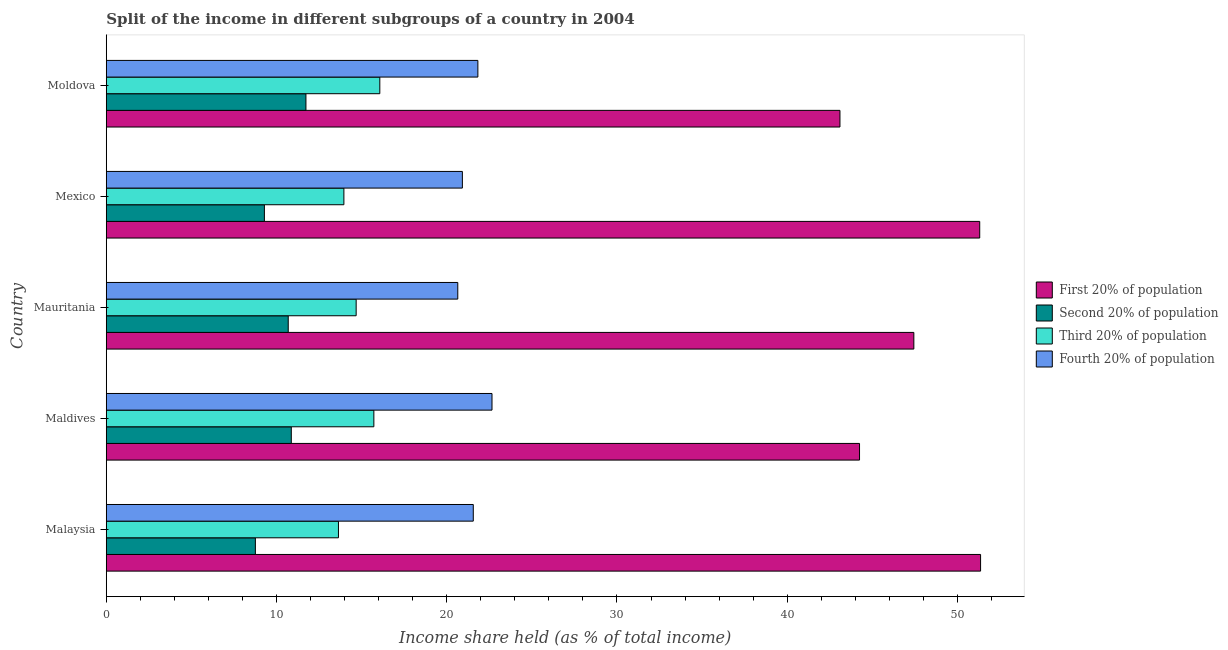How many groups of bars are there?
Your response must be concise. 5. Are the number of bars per tick equal to the number of legend labels?
Your answer should be compact. Yes. How many bars are there on the 2nd tick from the top?
Provide a succinct answer. 4. What is the label of the 4th group of bars from the top?
Keep it short and to the point. Maldives. In how many cases, is the number of bars for a given country not equal to the number of legend labels?
Offer a very short reply. 0. What is the share of the income held by third 20% of the population in Moldova?
Offer a very short reply. 16.07. Across all countries, what is the maximum share of the income held by first 20% of the population?
Your answer should be very brief. 51.36. Across all countries, what is the minimum share of the income held by third 20% of the population?
Provide a short and direct response. 13.64. In which country was the share of the income held by second 20% of the population maximum?
Give a very brief answer. Moldova. In which country was the share of the income held by first 20% of the population minimum?
Your answer should be very brief. Moldova. What is the total share of the income held by third 20% of the population in the graph?
Your answer should be very brief. 74.07. What is the difference between the share of the income held by fourth 20% of the population in Malaysia and that in Mauritania?
Make the answer very short. 0.91. What is the difference between the share of the income held by third 20% of the population in Mexico and the share of the income held by fourth 20% of the population in Mauritania?
Your answer should be very brief. -6.69. What is the average share of the income held by third 20% of the population per country?
Your response must be concise. 14.81. What is the difference between the share of the income held by second 20% of the population and share of the income held by fourth 20% of the population in Maldives?
Give a very brief answer. -11.79. In how many countries, is the share of the income held by first 20% of the population greater than 44 %?
Give a very brief answer. 4. What is the ratio of the share of the income held by first 20% of the population in Mauritania to that in Mexico?
Offer a terse response. 0.93. Is the share of the income held by second 20% of the population in Maldives less than that in Mexico?
Ensure brevity in your answer.  No. Is the difference between the share of the income held by first 20% of the population in Maldives and Mauritania greater than the difference between the share of the income held by second 20% of the population in Maldives and Mauritania?
Provide a short and direct response. No. What is the difference between the highest and the second highest share of the income held by third 20% of the population?
Offer a terse response. 0.35. What is the difference between the highest and the lowest share of the income held by second 20% of the population?
Keep it short and to the point. 2.97. Is it the case that in every country, the sum of the share of the income held by third 20% of the population and share of the income held by first 20% of the population is greater than the sum of share of the income held by fourth 20% of the population and share of the income held by second 20% of the population?
Ensure brevity in your answer.  Yes. What does the 3rd bar from the top in Mexico represents?
Offer a very short reply. Second 20% of population. What does the 2nd bar from the bottom in Mexico represents?
Give a very brief answer. Second 20% of population. Is it the case that in every country, the sum of the share of the income held by first 20% of the population and share of the income held by second 20% of the population is greater than the share of the income held by third 20% of the population?
Keep it short and to the point. Yes. How many bars are there?
Ensure brevity in your answer.  20. What is the difference between two consecutive major ticks on the X-axis?
Provide a short and direct response. 10. Are the values on the major ticks of X-axis written in scientific E-notation?
Give a very brief answer. No. How many legend labels are there?
Keep it short and to the point. 4. What is the title of the graph?
Provide a succinct answer. Split of the income in different subgroups of a country in 2004. Does "Grants and Revenue" appear as one of the legend labels in the graph?
Your answer should be very brief. No. What is the label or title of the X-axis?
Provide a short and direct response. Income share held (as % of total income). What is the Income share held (as % of total income) in First 20% of population in Malaysia?
Give a very brief answer. 51.36. What is the Income share held (as % of total income) in Second 20% of population in Malaysia?
Make the answer very short. 8.76. What is the Income share held (as % of total income) in Third 20% of population in Malaysia?
Offer a terse response. 13.64. What is the Income share held (as % of total income) in Fourth 20% of population in Malaysia?
Provide a succinct answer. 21.56. What is the Income share held (as % of total income) of First 20% of population in Maldives?
Make the answer very short. 44.25. What is the Income share held (as % of total income) of Second 20% of population in Maldives?
Give a very brief answer. 10.87. What is the Income share held (as % of total income) of Third 20% of population in Maldives?
Your response must be concise. 15.72. What is the Income share held (as % of total income) of Fourth 20% of population in Maldives?
Offer a terse response. 22.66. What is the Income share held (as % of total income) of First 20% of population in Mauritania?
Provide a succinct answer. 47.44. What is the Income share held (as % of total income) in Second 20% of population in Mauritania?
Offer a very short reply. 10.69. What is the Income share held (as % of total income) in Third 20% of population in Mauritania?
Provide a short and direct response. 14.68. What is the Income share held (as % of total income) in Fourth 20% of population in Mauritania?
Make the answer very short. 20.65. What is the Income share held (as % of total income) of First 20% of population in Mexico?
Offer a very short reply. 51.31. What is the Income share held (as % of total income) in Second 20% of population in Mexico?
Your answer should be very brief. 9.29. What is the Income share held (as % of total income) of Third 20% of population in Mexico?
Your response must be concise. 13.96. What is the Income share held (as % of total income) of Fourth 20% of population in Mexico?
Give a very brief answer. 20.92. What is the Income share held (as % of total income) in First 20% of population in Moldova?
Give a very brief answer. 43.1. What is the Income share held (as % of total income) of Second 20% of population in Moldova?
Provide a succinct answer. 11.73. What is the Income share held (as % of total income) in Third 20% of population in Moldova?
Your answer should be compact. 16.07. What is the Income share held (as % of total income) in Fourth 20% of population in Moldova?
Offer a terse response. 21.83. Across all countries, what is the maximum Income share held (as % of total income) of First 20% of population?
Offer a very short reply. 51.36. Across all countries, what is the maximum Income share held (as % of total income) in Second 20% of population?
Your answer should be very brief. 11.73. Across all countries, what is the maximum Income share held (as % of total income) in Third 20% of population?
Ensure brevity in your answer.  16.07. Across all countries, what is the maximum Income share held (as % of total income) in Fourth 20% of population?
Keep it short and to the point. 22.66. Across all countries, what is the minimum Income share held (as % of total income) of First 20% of population?
Keep it short and to the point. 43.1. Across all countries, what is the minimum Income share held (as % of total income) in Second 20% of population?
Ensure brevity in your answer.  8.76. Across all countries, what is the minimum Income share held (as % of total income) in Third 20% of population?
Ensure brevity in your answer.  13.64. Across all countries, what is the minimum Income share held (as % of total income) in Fourth 20% of population?
Provide a succinct answer. 20.65. What is the total Income share held (as % of total income) of First 20% of population in the graph?
Ensure brevity in your answer.  237.46. What is the total Income share held (as % of total income) in Second 20% of population in the graph?
Provide a succinct answer. 51.34. What is the total Income share held (as % of total income) in Third 20% of population in the graph?
Provide a succinct answer. 74.07. What is the total Income share held (as % of total income) of Fourth 20% of population in the graph?
Give a very brief answer. 107.62. What is the difference between the Income share held (as % of total income) of First 20% of population in Malaysia and that in Maldives?
Make the answer very short. 7.11. What is the difference between the Income share held (as % of total income) in Second 20% of population in Malaysia and that in Maldives?
Offer a very short reply. -2.11. What is the difference between the Income share held (as % of total income) of Third 20% of population in Malaysia and that in Maldives?
Your answer should be compact. -2.08. What is the difference between the Income share held (as % of total income) in Fourth 20% of population in Malaysia and that in Maldives?
Ensure brevity in your answer.  -1.1. What is the difference between the Income share held (as % of total income) in First 20% of population in Malaysia and that in Mauritania?
Offer a terse response. 3.92. What is the difference between the Income share held (as % of total income) of Second 20% of population in Malaysia and that in Mauritania?
Ensure brevity in your answer.  -1.93. What is the difference between the Income share held (as % of total income) in Third 20% of population in Malaysia and that in Mauritania?
Make the answer very short. -1.04. What is the difference between the Income share held (as % of total income) of Fourth 20% of population in Malaysia and that in Mauritania?
Your answer should be compact. 0.91. What is the difference between the Income share held (as % of total income) in Second 20% of population in Malaysia and that in Mexico?
Keep it short and to the point. -0.53. What is the difference between the Income share held (as % of total income) in Third 20% of population in Malaysia and that in Mexico?
Keep it short and to the point. -0.32. What is the difference between the Income share held (as % of total income) in Fourth 20% of population in Malaysia and that in Mexico?
Keep it short and to the point. 0.64. What is the difference between the Income share held (as % of total income) of First 20% of population in Malaysia and that in Moldova?
Your answer should be very brief. 8.26. What is the difference between the Income share held (as % of total income) in Second 20% of population in Malaysia and that in Moldova?
Your response must be concise. -2.97. What is the difference between the Income share held (as % of total income) of Third 20% of population in Malaysia and that in Moldova?
Your answer should be very brief. -2.43. What is the difference between the Income share held (as % of total income) of Fourth 20% of population in Malaysia and that in Moldova?
Offer a terse response. -0.27. What is the difference between the Income share held (as % of total income) of First 20% of population in Maldives and that in Mauritania?
Provide a succinct answer. -3.19. What is the difference between the Income share held (as % of total income) of Second 20% of population in Maldives and that in Mauritania?
Provide a short and direct response. 0.18. What is the difference between the Income share held (as % of total income) of Fourth 20% of population in Maldives and that in Mauritania?
Offer a very short reply. 2.01. What is the difference between the Income share held (as % of total income) in First 20% of population in Maldives and that in Mexico?
Your answer should be compact. -7.06. What is the difference between the Income share held (as % of total income) of Second 20% of population in Maldives and that in Mexico?
Keep it short and to the point. 1.58. What is the difference between the Income share held (as % of total income) in Third 20% of population in Maldives and that in Mexico?
Make the answer very short. 1.76. What is the difference between the Income share held (as % of total income) in Fourth 20% of population in Maldives and that in Mexico?
Your response must be concise. 1.74. What is the difference between the Income share held (as % of total income) in First 20% of population in Maldives and that in Moldova?
Offer a terse response. 1.15. What is the difference between the Income share held (as % of total income) in Second 20% of population in Maldives and that in Moldova?
Provide a short and direct response. -0.86. What is the difference between the Income share held (as % of total income) of Third 20% of population in Maldives and that in Moldova?
Provide a succinct answer. -0.35. What is the difference between the Income share held (as % of total income) in Fourth 20% of population in Maldives and that in Moldova?
Provide a succinct answer. 0.83. What is the difference between the Income share held (as % of total income) of First 20% of population in Mauritania and that in Mexico?
Offer a very short reply. -3.87. What is the difference between the Income share held (as % of total income) of Third 20% of population in Mauritania and that in Mexico?
Ensure brevity in your answer.  0.72. What is the difference between the Income share held (as % of total income) of Fourth 20% of population in Mauritania and that in Mexico?
Offer a terse response. -0.27. What is the difference between the Income share held (as % of total income) of First 20% of population in Mauritania and that in Moldova?
Provide a short and direct response. 4.34. What is the difference between the Income share held (as % of total income) in Second 20% of population in Mauritania and that in Moldova?
Your answer should be compact. -1.04. What is the difference between the Income share held (as % of total income) in Third 20% of population in Mauritania and that in Moldova?
Your response must be concise. -1.39. What is the difference between the Income share held (as % of total income) of Fourth 20% of population in Mauritania and that in Moldova?
Provide a succinct answer. -1.18. What is the difference between the Income share held (as % of total income) of First 20% of population in Mexico and that in Moldova?
Offer a very short reply. 8.21. What is the difference between the Income share held (as % of total income) in Second 20% of population in Mexico and that in Moldova?
Your response must be concise. -2.44. What is the difference between the Income share held (as % of total income) of Third 20% of population in Mexico and that in Moldova?
Provide a succinct answer. -2.11. What is the difference between the Income share held (as % of total income) in Fourth 20% of population in Mexico and that in Moldova?
Your response must be concise. -0.91. What is the difference between the Income share held (as % of total income) in First 20% of population in Malaysia and the Income share held (as % of total income) in Second 20% of population in Maldives?
Your answer should be very brief. 40.49. What is the difference between the Income share held (as % of total income) in First 20% of population in Malaysia and the Income share held (as % of total income) in Third 20% of population in Maldives?
Your answer should be compact. 35.64. What is the difference between the Income share held (as % of total income) of First 20% of population in Malaysia and the Income share held (as % of total income) of Fourth 20% of population in Maldives?
Offer a terse response. 28.7. What is the difference between the Income share held (as % of total income) of Second 20% of population in Malaysia and the Income share held (as % of total income) of Third 20% of population in Maldives?
Ensure brevity in your answer.  -6.96. What is the difference between the Income share held (as % of total income) in Third 20% of population in Malaysia and the Income share held (as % of total income) in Fourth 20% of population in Maldives?
Ensure brevity in your answer.  -9.02. What is the difference between the Income share held (as % of total income) in First 20% of population in Malaysia and the Income share held (as % of total income) in Second 20% of population in Mauritania?
Make the answer very short. 40.67. What is the difference between the Income share held (as % of total income) in First 20% of population in Malaysia and the Income share held (as % of total income) in Third 20% of population in Mauritania?
Ensure brevity in your answer.  36.68. What is the difference between the Income share held (as % of total income) in First 20% of population in Malaysia and the Income share held (as % of total income) in Fourth 20% of population in Mauritania?
Offer a terse response. 30.71. What is the difference between the Income share held (as % of total income) of Second 20% of population in Malaysia and the Income share held (as % of total income) of Third 20% of population in Mauritania?
Provide a succinct answer. -5.92. What is the difference between the Income share held (as % of total income) in Second 20% of population in Malaysia and the Income share held (as % of total income) in Fourth 20% of population in Mauritania?
Offer a very short reply. -11.89. What is the difference between the Income share held (as % of total income) in Third 20% of population in Malaysia and the Income share held (as % of total income) in Fourth 20% of population in Mauritania?
Your answer should be compact. -7.01. What is the difference between the Income share held (as % of total income) of First 20% of population in Malaysia and the Income share held (as % of total income) of Second 20% of population in Mexico?
Provide a short and direct response. 42.07. What is the difference between the Income share held (as % of total income) of First 20% of population in Malaysia and the Income share held (as % of total income) of Third 20% of population in Mexico?
Your response must be concise. 37.4. What is the difference between the Income share held (as % of total income) in First 20% of population in Malaysia and the Income share held (as % of total income) in Fourth 20% of population in Mexico?
Ensure brevity in your answer.  30.44. What is the difference between the Income share held (as % of total income) of Second 20% of population in Malaysia and the Income share held (as % of total income) of Third 20% of population in Mexico?
Provide a short and direct response. -5.2. What is the difference between the Income share held (as % of total income) of Second 20% of population in Malaysia and the Income share held (as % of total income) of Fourth 20% of population in Mexico?
Your response must be concise. -12.16. What is the difference between the Income share held (as % of total income) in Third 20% of population in Malaysia and the Income share held (as % of total income) in Fourth 20% of population in Mexico?
Your answer should be compact. -7.28. What is the difference between the Income share held (as % of total income) of First 20% of population in Malaysia and the Income share held (as % of total income) of Second 20% of population in Moldova?
Provide a short and direct response. 39.63. What is the difference between the Income share held (as % of total income) of First 20% of population in Malaysia and the Income share held (as % of total income) of Third 20% of population in Moldova?
Offer a terse response. 35.29. What is the difference between the Income share held (as % of total income) in First 20% of population in Malaysia and the Income share held (as % of total income) in Fourth 20% of population in Moldova?
Keep it short and to the point. 29.53. What is the difference between the Income share held (as % of total income) of Second 20% of population in Malaysia and the Income share held (as % of total income) of Third 20% of population in Moldova?
Provide a short and direct response. -7.31. What is the difference between the Income share held (as % of total income) in Second 20% of population in Malaysia and the Income share held (as % of total income) in Fourth 20% of population in Moldova?
Offer a terse response. -13.07. What is the difference between the Income share held (as % of total income) of Third 20% of population in Malaysia and the Income share held (as % of total income) of Fourth 20% of population in Moldova?
Your response must be concise. -8.19. What is the difference between the Income share held (as % of total income) in First 20% of population in Maldives and the Income share held (as % of total income) in Second 20% of population in Mauritania?
Provide a short and direct response. 33.56. What is the difference between the Income share held (as % of total income) of First 20% of population in Maldives and the Income share held (as % of total income) of Third 20% of population in Mauritania?
Your response must be concise. 29.57. What is the difference between the Income share held (as % of total income) of First 20% of population in Maldives and the Income share held (as % of total income) of Fourth 20% of population in Mauritania?
Keep it short and to the point. 23.6. What is the difference between the Income share held (as % of total income) of Second 20% of population in Maldives and the Income share held (as % of total income) of Third 20% of population in Mauritania?
Offer a terse response. -3.81. What is the difference between the Income share held (as % of total income) of Second 20% of population in Maldives and the Income share held (as % of total income) of Fourth 20% of population in Mauritania?
Offer a terse response. -9.78. What is the difference between the Income share held (as % of total income) of Third 20% of population in Maldives and the Income share held (as % of total income) of Fourth 20% of population in Mauritania?
Ensure brevity in your answer.  -4.93. What is the difference between the Income share held (as % of total income) in First 20% of population in Maldives and the Income share held (as % of total income) in Second 20% of population in Mexico?
Your answer should be very brief. 34.96. What is the difference between the Income share held (as % of total income) of First 20% of population in Maldives and the Income share held (as % of total income) of Third 20% of population in Mexico?
Your response must be concise. 30.29. What is the difference between the Income share held (as % of total income) in First 20% of population in Maldives and the Income share held (as % of total income) in Fourth 20% of population in Mexico?
Your response must be concise. 23.33. What is the difference between the Income share held (as % of total income) in Second 20% of population in Maldives and the Income share held (as % of total income) in Third 20% of population in Mexico?
Make the answer very short. -3.09. What is the difference between the Income share held (as % of total income) in Second 20% of population in Maldives and the Income share held (as % of total income) in Fourth 20% of population in Mexico?
Offer a terse response. -10.05. What is the difference between the Income share held (as % of total income) in Third 20% of population in Maldives and the Income share held (as % of total income) in Fourth 20% of population in Mexico?
Give a very brief answer. -5.2. What is the difference between the Income share held (as % of total income) of First 20% of population in Maldives and the Income share held (as % of total income) of Second 20% of population in Moldova?
Offer a terse response. 32.52. What is the difference between the Income share held (as % of total income) in First 20% of population in Maldives and the Income share held (as % of total income) in Third 20% of population in Moldova?
Your response must be concise. 28.18. What is the difference between the Income share held (as % of total income) of First 20% of population in Maldives and the Income share held (as % of total income) of Fourth 20% of population in Moldova?
Your answer should be very brief. 22.42. What is the difference between the Income share held (as % of total income) in Second 20% of population in Maldives and the Income share held (as % of total income) in Fourth 20% of population in Moldova?
Offer a terse response. -10.96. What is the difference between the Income share held (as % of total income) in Third 20% of population in Maldives and the Income share held (as % of total income) in Fourth 20% of population in Moldova?
Your response must be concise. -6.11. What is the difference between the Income share held (as % of total income) of First 20% of population in Mauritania and the Income share held (as % of total income) of Second 20% of population in Mexico?
Offer a terse response. 38.15. What is the difference between the Income share held (as % of total income) in First 20% of population in Mauritania and the Income share held (as % of total income) in Third 20% of population in Mexico?
Give a very brief answer. 33.48. What is the difference between the Income share held (as % of total income) of First 20% of population in Mauritania and the Income share held (as % of total income) of Fourth 20% of population in Mexico?
Make the answer very short. 26.52. What is the difference between the Income share held (as % of total income) of Second 20% of population in Mauritania and the Income share held (as % of total income) of Third 20% of population in Mexico?
Keep it short and to the point. -3.27. What is the difference between the Income share held (as % of total income) in Second 20% of population in Mauritania and the Income share held (as % of total income) in Fourth 20% of population in Mexico?
Your answer should be very brief. -10.23. What is the difference between the Income share held (as % of total income) of Third 20% of population in Mauritania and the Income share held (as % of total income) of Fourth 20% of population in Mexico?
Your answer should be very brief. -6.24. What is the difference between the Income share held (as % of total income) of First 20% of population in Mauritania and the Income share held (as % of total income) of Second 20% of population in Moldova?
Ensure brevity in your answer.  35.71. What is the difference between the Income share held (as % of total income) of First 20% of population in Mauritania and the Income share held (as % of total income) of Third 20% of population in Moldova?
Provide a succinct answer. 31.37. What is the difference between the Income share held (as % of total income) of First 20% of population in Mauritania and the Income share held (as % of total income) of Fourth 20% of population in Moldova?
Keep it short and to the point. 25.61. What is the difference between the Income share held (as % of total income) of Second 20% of population in Mauritania and the Income share held (as % of total income) of Third 20% of population in Moldova?
Your answer should be very brief. -5.38. What is the difference between the Income share held (as % of total income) of Second 20% of population in Mauritania and the Income share held (as % of total income) of Fourth 20% of population in Moldova?
Offer a terse response. -11.14. What is the difference between the Income share held (as % of total income) in Third 20% of population in Mauritania and the Income share held (as % of total income) in Fourth 20% of population in Moldova?
Provide a short and direct response. -7.15. What is the difference between the Income share held (as % of total income) in First 20% of population in Mexico and the Income share held (as % of total income) in Second 20% of population in Moldova?
Keep it short and to the point. 39.58. What is the difference between the Income share held (as % of total income) of First 20% of population in Mexico and the Income share held (as % of total income) of Third 20% of population in Moldova?
Offer a terse response. 35.24. What is the difference between the Income share held (as % of total income) of First 20% of population in Mexico and the Income share held (as % of total income) of Fourth 20% of population in Moldova?
Give a very brief answer. 29.48. What is the difference between the Income share held (as % of total income) of Second 20% of population in Mexico and the Income share held (as % of total income) of Third 20% of population in Moldova?
Offer a very short reply. -6.78. What is the difference between the Income share held (as % of total income) in Second 20% of population in Mexico and the Income share held (as % of total income) in Fourth 20% of population in Moldova?
Provide a succinct answer. -12.54. What is the difference between the Income share held (as % of total income) in Third 20% of population in Mexico and the Income share held (as % of total income) in Fourth 20% of population in Moldova?
Your answer should be very brief. -7.87. What is the average Income share held (as % of total income) of First 20% of population per country?
Offer a very short reply. 47.49. What is the average Income share held (as % of total income) in Second 20% of population per country?
Ensure brevity in your answer.  10.27. What is the average Income share held (as % of total income) in Third 20% of population per country?
Offer a very short reply. 14.81. What is the average Income share held (as % of total income) of Fourth 20% of population per country?
Offer a terse response. 21.52. What is the difference between the Income share held (as % of total income) of First 20% of population and Income share held (as % of total income) of Second 20% of population in Malaysia?
Make the answer very short. 42.6. What is the difference between the Income share held (as % of total income) of First 20% of population and Income share held (as % of total income) of Third 20% of population in Malaysia?
Make the answer very short. 37.72. What is the difference between the Income share held (as % of total income) in First 20% of population and Income share held (as % of total income) in Fourth 20% of population in Malaysia?
Your response must be concise. 29.8. What is the difference between the Income share held (as % of total income) of Second 20% of population and Income share held (as % of total income) of Third 20% of population in Malaysia?
Offer a very short reply. -4.88. What is the difference between the Income share held (as % of total income) in Third 20% of population and Income share held (as % of total income) in Fourth 20% of population in Malaysia?
Offer a very short reply. -7.92. What is the difference between the Income share held (as % of total income) of First 20% of population and Income share held (as % of total income) of Second 20% of population in Maldives?
Make the answer very short. 33.38. What is the difference between the Income share held (as % of total income) in First 20% of population and Income share held (as % of total income) in Third 20% of population in Maldives?
Give a very brief answer. 28.53. What is the difference between the Income share held (as % of total income) in First 20% of population and Income share held (as % of total income) in Fourth 20% of population in Maldives?
Offer a very short reply. 21.59. What is the difference between the Income share held (as % of total income) of Second 20% of population and Income share held (as % of total income) of Third 20% of population in Maldives?
Offer a very short reply. -4.85. What is the difference between the Income share held (as % of total income) in Second 20% of population and Income share held (as % of total income) in Fourth 20% of population in Maldives?
Offer a terse response. -11.79. What is the difference between the Income share held (as % of total income) in Third 20% of population and Income share held (as % of total income) in Fourth 20% of population in Maldives?
Your response must be concise. -6.94. What is the difference between the Income share held (as % of total income) in First 20% of population and Income share held (as % of total income) in Second 20% of population in Mauritania?
Give a very brief answer. 36.75. What is the difference between the Income share held (as % of total income) in First 20% of population and Income share held (as % of total income) in Third 20% of population in Mauritania?
Your response must be concise. 32.76. What is the difference between the Income share held (as % of total income) of First 20% of population and Income share held (as % of total income) of Fourth 20% of population in Mauritania?
Give a very brief answer. 26.79. What is the difference between the Income share held (as % of total income) in Second 20% of population and Income share held (as % of total income) in Third 20% of population in Mauritania?
Ensure brevity in your answer.  -3.99. What is the difference between the Income share held (as % of total income) in Second 20% of population and Income share held (as % of total income) in Fourth 20% of population in Mauritania?
Provide a short and direct response. -9.96. What is the difference between the Income share held (as % of total income) in Third 20% of population and Income share held (as % of total income) in Fourth 20% of population in Mauritania?
Your response must be concise. -5.97. What is the difference between the Income share held (as % of total income) in First 20% of population and Income share held (as % of total income) in Second 20% of population in Mexico?
Offer a very short reply. 42.02. What is the difference between the Income share held (as % of total income) in First 20% of population and Income share held (as % of total income) in Third 20% of population in Mexico?
Your answer should be compact. 37.35. What is the difference between the Income share held (as % of total income) of First 20% of population and Income share held (as % of total income) of Fourth 20% of population in Mexico?
Keep it short and to the point. 30.39. What is the difference between the Income share held (as % of total income) of Second 20% of population and Income share held (as % of total income) of Third 20% of population in Mexico?
Offer a terse response. -4.67. What is the difference between the Income share held (as % of total income) of Second 20% of population and Income share held (as % of total income) of Fourth 20% of population in Mexico?
Give a very brief answer. -11.63. What is the difference between the Income share held (as % of total income) in Third 20% of population and Income share held (as % of total income) in Fourth 20% of population in Mexico?
Make the answer very short. -6.96. What is the difference between the Income share held (as % of total income) in First 20% of population and Income share held (as % of total income) in Second 20% of population in Moldova?
Give a very brief answer. 31.37. What is the difference between the Income share held (as % of total income) of First 20% of population and Income share held (as % of total income) of Third 20% of population in Moldova?
Give a very brief answer. 27.03. What is the difference between the Income share held (as % of total income) of First 20% of population and Income share held (as % of total income) of Fourth 20% of population in Moldova?
Ensure brevity in your answer.  21.27. What is the difference between the Income share held (as % of total income) in Second 20% of population and Income share held (as % of total income) in Third 20% of population in Moldova?
Make the answer very short. -4.34. What is the difference between the Income share held (as % of total income) of Second 20% of population and Income share held (as % of total income) of Fourth 20% of population in Moldova?
Provide a short and direct response. -10.1. What is the difference between the Income share held (as % of total income) of Third 20% of population and Income share held (as % of total income) of Fourth 20% of population in Moldova?
Offer a terse response. -5.76. What is the ratio of the Income share held (as % of total income) in First 20% of population in Malaysia to that in Maldives?
Give a very brief answer. 1.16. What is the ratio of the Income share held (as % of total income) in Second 20% of population in Malaysia to that in Maldives?
Offer a very short reply. 0.81. What is the ratio of the Income share held (as % of total income) of Third 20% of population in Malaysia to that in Maldives?
Provide a short and direct response. 0.87. What is the ratio of the Income share held (as % of total income) of Fourth 20% of population in Malaysia to that in Maldives?
Your answer should be compact. 0.95. What is the ratio of the Income share held (as % of total income) of First 20% of population in Malaysia to that in Mauritania?
Give a very brief answer. 1.08. What is the ratio of the Income share held (as % of total income) in Second 20% of population in Malaysia to that in Mauritania?
Give a very brief answer. 0.82. What is the ratio of the Income share held (as % of total income) of Third 20% of population in Malaysia to that in Mauritania?
Keep it short and to the point. 0.93. What is the ratio of the Income share held (as % of total income) of Fourth 20% of population in Malaysia to that in Mauritania?
Your answer should be compact. 1.04. What is the ratio of the Income share held (as % of total income) in First 20% of population in Malaysia to that in Mexico?
Give a very brief answer. 1. What is the ratio of the Income share held (as % of total income) in Second 20% of population in Malaysia to that in Mexico?
Your answer should be compact. 0.94. What is the ratio of the Income share held (as % of total income) in Third 20% of population in Malaysia to that in Mexico?
Keep it short and to the point. 0.98. What is the ratio of the Income share held (as % of total income) in Fourth 20% of population in Malaysia to that in Mexico?
Provide a succinct answer. 1.03. What is the ratio of the Income share held (as % of total income) of First 20% of population in Malaysia to that in Moldova?
Your answer should be very brief. 1.19. What is the ratio of the Income share held (as % of total income) in Second 20% of population in Malaysia to that in Moldova?
Give a very brief answer. 0.75. What is the ratio of the Income share held (as % of total income) of Third 20% of population in Malaysia to that in Moldova?
Your answer should be very brief. 0.85. What is the ratio of the Income share held (as % of total income) of Fourth 20% of population in Malaysia to that in Moldova?
Your response must be concise. 0.99. What is the ratio of the Income share held (as % of total income) in First 20% of population in Maldives to that in Mauritania?
Keep it short and to the point. 0.93. What is the ratio of the Income share held (as % of total income) of Second 20% of population in Maldives to that in Mauritania?
Provide a succinct answer. 1.02. What is the ratio of the Income share held (as % of total income) in Third 20% of population in Maldives to that in Mauritania?
Your answer should be very brief. 1.07. What is the ratio of the Income share held (as % of total income) in Fourth 20% of population in Maldives to that in Mauritania?
Offer a very short reply. 1.1. What is the ratio of the Income share held (as % of total income) of First 20% of population in Maldives to that in Mexico?
Give a very brief answer. 0.86. What is the ratio of the Income share held (as % of total income) of Second 20% of population in Maldives to that in Mexico?
Provide a succinct answer. 1.17. What is the ratio of the Income share held (as % of total income) of Third 20% of population in Maldives to that in Mexico?
Offer a very short reply. 1.13. What is the ratio of the Income share held (as % of total income) of Fourth 20% of population in Maldives to that in Mexico?
Provide a succinct answer. 1.08. What is the ratio of the Income share held (as % of total income) in First 20% of population in Maldives to that in Moldova?
Your answer should be compact. 1.03. What is the ratio of the Income share held (as % of total income) in Second 20% of population in Maldives to that in Moldova?
Keep it short and to the point. 0.93. What is the ratio of the Income share held (as % of total income) of Third 20% of population in Maldives to that in Moldova?
Provide a succinct answer. 0.98. What is the ratio of the Income share held (as % of total income) of Fourth 20% of population in Maldives to that in Moldova?
Provide a short and direct response. 1.04. What is the ratio of the Income share held (as % of total income) of First 20% of population in Mauritania to that in Mexico?
Your answer should be very brief. 0.92. What is the ratio of the Income share held (as % of total income) of Second 20% of population in Mauritania to that in Mexico?
Offer a very short reply. 1.15. What is the ratio of the Income share held (as % of total income) in Third 20% of population in Mauritania to that in Mexico?
Make the answer very short. 1.05. What is the ratio of the Income share held (as % of total income) in Fourth 20% of population in Mauritania to that in Mexico?
Keep it short and to the point. 0.99. What is the ratio of the Income share held (as % of total income) of First 20% of population in Mauritania to that in Moldova?
Make the answer very short. 1.1. What is the ratio of the Income share held (as % of total income) in Second 20% of population in Mauritania to that in Moldova?
Your answer should be very brief. 0.91. What is the ratio of the Income share held (as % of total income) of Third 20% of population in Mauritania to that in Moldova?
Your answer should be very brief. 0.91. What is the ratio of the Income share held (as % of total income) of Fourth 20% of population in Mauritania to that in Moldova?
Make the answer very short. 0.95. What is the ratio of the Income share held (as % of total income) in First 20% of population in Mexico to that in Moldova?
Ensure brevity in your answer.  1.19. What is the ratio of the Income share held (as % of total income) in Second 20% of population in Mexico to that in Moldova?
Your answer should be compact. 0.79. What is the ratio of the Income share held (as % of total income) of Third 20% of population in Mexico to that in Moldova?
Give a very brief answer. 0.87. What is the difference between the highest and the second highest Income share held (as % of total income) of First 20% of population?
Offer a very short reply. 0.05. What is the difference between the highest and the second highest Income share held (as % of total income) in Second 20% of population?
Your answer should be very brief. 0.86. What is the difference between the highest and the second highest Income share held (as % of total income) of Fourth 20% of population?
Give a very brief answer. 0.83. What is the difference between the highest and the lowest Income share held (as % of total income) of First 20% of population?
Your answer should be very brief. 8.26. What is the difference between the highest and the lowest Income share held (as % of total income) of Second 20% of population?
Provide a short and direct response. 2.97. What is the difference between the highest and the lowest Income share held (as % of total income) of Third 20% of population?
Offer a terse response. 2.43. What is the difference between the highest and the lowest Income share held (as % of total income) of Fourth 20% of population?
Keep it short and to the point. 2.01. 